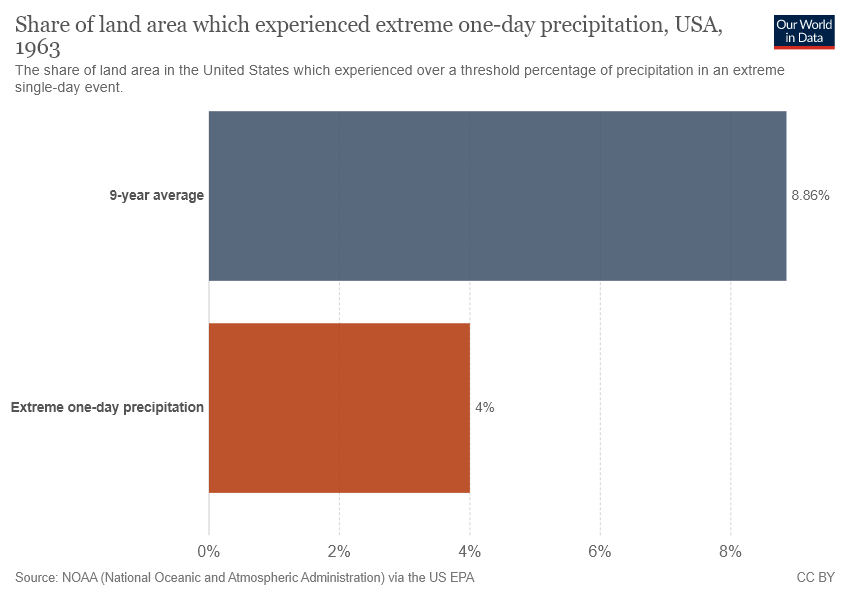Point out several critical features in this image. The difference in value between both bars is 0.0486... The value of the largest bar is approximately 0.0886. 